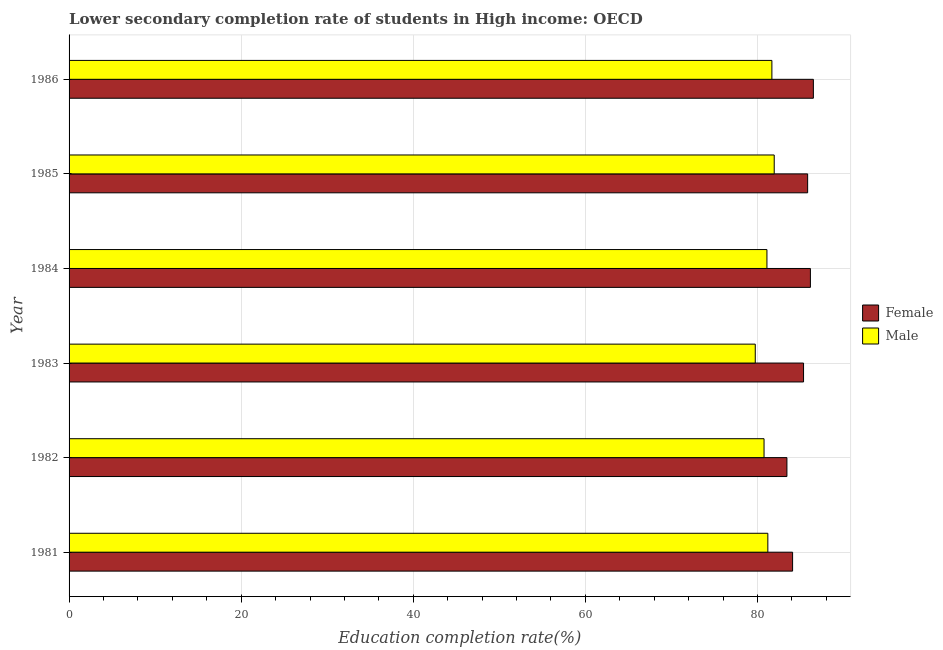How many different coloured bars are there?
Your response must be concise. 2. How many groups of bars are there?
Give a very brief answer. 6. Are the number of bars per tick equal to the number of legend labels?
Provide a short and direct response. Yes. Are the number of bars on each tick of the Y-axis equal?
Give a very brief answer. Yes. How many bars are there on the 3rd tick from the top?
Provide a short and direct response. 2. How many bars are there on the 1st tick from the bottom?
Make the answer very short. 2. What is the education completion rate of female students in 1982?
Offer a terse response. 83.43. Across all years, what is the maximum education completion rate of female students?
Offer a very short reply. 86.5. Across all years, what is the minimum education completion rate of male students?
Your answer should be compact. 79.75. In which year was the education completion rate of female students maximum?
Keep it short and to the point. 1986. In which year was the education completion rate of female students minimum?
Provide a succinct answer. 1982. What is the total education completion rate of male students in the graph?
Give a very brief answer. 486.46. What is the difference between the education completion rate of female students in 1981 and that in 1986?
Offer a terse response. -2.41. What is the difference between the education completion rate of female students in 1986 and the education completion rate of male students in 1983?
Your answer should be very brief. 6.75. What is the average education completion rate of male students per year?
Offer a very short reply. 81.08. In the year 1986, what is the difference between the education completion rate of female students and education completion rate of male students?
Make the answer very short. 4.82. In how many years, is the education completion rate of female students greater than 84 %?
Make the answer very short. 5. What is the ratio of the education completion rate of female students in 1983 to that in 1986?
Provide a short and direct response. 0.99. What is the difference between the highest and the second highest education completion rate of male students?
Provide a short and direct response. 0.27. What is the difference between the highest and the lowest education completion rate of male students?
Provide a short and direct response. 2.2. Is the sum of the education completion rate of male students in 1985 and 1986 greater than the maximum education completion rate of female students across all years?
Provide a succinct answer. Yes. What does the 1st bar from the top in 1983 represents?
Provide a succinct answer. Male. What does the 2nd bar from the bottom in 1985 represents?
Your answer should be compact. Male. Are all the bars in the graph horizontal?
Offer a very short reply. Yes. What is the difference between two consecutive major ticks on the X-axis?
Your answer should be very brief. 20. Are the values on the major ticks of X-axis written in scientific E-notation?
Make the answer very short. No. Does the graph contain grids?
Your response must be concise. Yes. Where does the legend appear in the graph?
Your answer should be compact. Center right. How many legend labels are there?
Your response must be concise. 2. How are the legend labels stacked?
Ensure brevity in your answer.  Vertical. What is the title of the graph?
Provide a succinct answer. Lower secondary completion rate of students in High income: OECD. Does "Females" appear as one of the legend labels in the graph?
Give a very brief answer. No. What is the label or title of the X-axis?
Provide a succinct answer. Education completion rate(%). What is the Education completion rate(%) in Female in 1981?
Provide a short and direct response. 84.09. What is the Education completion rate(%) in Male in 1981?
Ensure brevity in your answer.  81.21. What is the Education completion rate(%) in Female in 1982?
Provide a succinct answer. 83.43. What is the Education completion rate(%) of Male in 1982?
Your answer should be compact. 80.77. What is the Education completion rate(%) in Female in 1983?
Keep it short and to the point. 85.36. What is the Education completion rate(%) in Male in 1983?
Provide a short and direct response. 79.75. What is the Education completion rate(%) of Female in 1984?
Provide a succinct answer. 86.16. What is the Education completion rate(%) of Male in 1984?
Your response must be concise. 81.1. What is the Education completion rate(%) of Female in 1985?
Your answer should be compact. 85.83. What is the Education completion rate(%) of Male in 1985?
Provide a short and direct response. 81.95. What is the Education completion rate(%) in Female in 1986?
Provide a succinct answer. 86.5. What is the Education completion rate(%) in Male in 1986?
Your answer should be compact. 81.68. Across all years, what is the maximum Education completion rate(%) of Female?
Provide a short and direct response. 86.5. Across all years, what is the maximum Education completion rate(%) of Male?
Your answer should be very brief. 81.95. Across all years, what is the minimum Education completion rate(%) in Female?
Provide a succinct answer. 83.43. Across all years, what is the minimum Education completion rate(%) of Male?
Give a very brief answer. 79.75. What is the total Education completion rate(%) in Female in the graph?
Offer a terse response. 511.36. What is the total Education completion rate(%) of Male in the graph?
Keep it short and to the point. 486.46. What is the difference between the Education completion rate(%) of Female in 1981 and that in 1982?
Ensure brevity in your answer.  0.66. What is the difference between the Education completion rate(%) of Male in 1981 and that in 1982?
Provide a succinct answer. 0.44. What is the difference between the Education completion rate(%) in Female in 1981 and that in 1983?
Your answer should be compact. -1.27. What is the difference between the Education completion rate(%) in Male in 1981 and that in 1983?
Ensure brevity in your answer.  1.46. What is the difference between the Education completion rate(%) in Female in 1981 and that in 1984?
Keep it short and to the point. -2.07. What is the difference between the Education completion rate(%) in Male in 1981 and that in 1984?
Provide a succinct answer. 0.11. What is the difference between the Education completion rate(%) of Female in 1981 and that in 1985?
Make the answer very short. -1.75. What is the difference between the Education completion rate(%) of Male in 1981 and that in 1985?
Keep it short and to the point. -0.74. What is the difference between the Education completion rate(%) of Female in 1981 and that in 1986?
Your response must be concise. -2.41. What is the difference between the Education completion rate(%) in Male in 1981 and that in 1986?
Provide a short and direct response. -0.47. What is the difference between the Education completion rate(%) of Female in 1982 and that in 1983?
Give a very brief answer. -1.93. What is the difference between the Education completion rate(%) of Male in 1982 and that in 1983?
Offer a very short reply. 1.02. What is the difference between the Education completion rate(%) of Female in 1982 and that in 1984?
Provide a short and direct response. -2.73. What is the difference between the Education completion rate(%) of Male in 1982 and that in 1984?
Offer a very short reply. -0.34. What is the difference between the Education completion rate(%) of Female in 1982 and that in 1985?
Offer a very short reply. -2.41. What is the difference between the Education completion rate(%) in Male in 1982 and that in 1985?
Your answer should be very brief. -1.18. What is the difference between the Education completion rate(%) in Female in 1982 and that in 1986?
Offer a very short reply. -3.07. What is the difference between the Education completion rate(%) in Male in 1982 and that in 1986?
Provide a short and direct response. -0.91. What is the difference between the Education completion rate(%) of Female in 1983 and that in 1984?
Provide a short and direct response. -0.8. What is the difference between the Education completion rate(%) of Male in 1983 and that in 1984?
Ensure brevity in your answer.  -1.36. What is the difference between the Education completion rate(%) of Female in 1983 and that in 1985?
Offer a very short reply. -0.48. What is the difference between the Education completion rate(%) of Male in 1983 and that in 1985?
Keep it short and to the point. -2.2. What is the difference between the Education completion rate(%) in Female in 1983 and that in 1986?
Provide a succinct answer. -1.14. What is the difference between the Education completion rate(%) of Male in 1983 and that in 1986?
Keep it short and to the point. -1.93. What is the difference between the Education completion rate(%) of Female in 1984 and that in 1985?
Give a very brief answer. 0.32. What is the difference between the Education completion rate(%) of Male in 1984 and that in 1985?
Provide a short and direct response. -0.85. What is the difference between the Education completion rate(%) in Female in 1984 and that in 1986?
Offer a terse response. -0.34. What is the difference between the Education completion rate(%) of Male in 1984 and that in 1986?
Your answer should be compact. -0.58. What is the difference between the Education completion rate(%) of Female in 1985 and that in 1986?
Make the answer very short. -0.67. What is the difference between the Education completion rate(%) in Male in 1985 and that in 1986?
Provide a succinct answer. 0.27. What is the difference between the Education completion rate(%) in Female in 1981 and the Education completion rate(%) in Male in 1982?
Ensure brevity in your answer.  3.32. What is the difference between the Education completion rate(%) of Female in 1981 and the Education completion rate(%) of Male in 1983?
Provide a succinct answer. 4.34. What is the difference between the Education completion rate(%) of Female in 1981 and the Education completion rate(%) of Male in 1984?
Ensure brevity in your answer.  2.98. What is the difference between the Education completion rate(%) in Female in 1981 and the Education completion rate(%) in Male in 1985?
Your answer should be very brief. 2.14. What is the difference between the Education completion rate(%) in Female in 1981 and the Education completion rate(%) in Male in 1986?
Ensure brevity in your answer.  2.41. What is the difference between the Education completion rate(%) of Female in 1982 and the Education completion rate(%) of Male in 1983?
Ensure brevity in your answer.  3.68. What is the difference between the Education completion rate(%) in Female in 1982 and the Education completion rate(%) in Male in 1984?
Offer a terse response. 2.32. What is the difference between the Education completion rate(%) of Female in 1982 and the Education completion rate(%) of Male in 1985?
Provide a short and direct response. 1.48. What is the difference between the Education completion rate(%) of Female in 1982 and the Education completion rate(%) of Male in 1986?
Keep it short and to the point. 1.75. What is the difference between the Education completion rate(%) of Female in 1983 and the Education completion rate(%) of Male in 1984?
Provide a succinct answer. 4.25. What is the difference between the Education completion rate(%) of Female in 1983 and the Education completion rate(%) of Male in 1985?
Your response must be concise. 3.41. What is the difference between the Education completion rate(%) of Female in 1983 and the Education completion rate(%) of Male in 1986?
Provide a short and direct response. 3.68. What is the difference between the Education completion rate(%) in Female in 1984 and the Education completion rate(%) in Male in 1985?
Your response must be concise. 4.21. What is the difference between the Education completion rate(%) in Female in 1984 and the Education completion rate(%) in Male in 1986?
Provide a short and direct response. 4.48. What is the difference between the Education completion rate(%) in Female in 1985 and the Education completion rate(%) in Male in 1986?
Your response must be concise. 4.15. What is the average Education completion rate(%) of Female per year?
Your answer should be compact. 85.23. What is the average Education completion rate(%) of Male per year?
Your answer should be compact. 81.08. In the year 1981, what is the difference between the Education completion rate(%) of Female and Education completion rate(%) of Male?
Give a very brief answer. 2.88. In the year 1982, what is the difference between the Education completion rate(%) in Female and Education completion rate(%) in Male?
Your answer should be compact. 2.66. In the year 1983, what is the difference between the Education completion rate(%) of Female and Education completion rate(%) of Male?
Your answer should be compact. 5.61. In the year 1984, what is the difference between the Education completion rate(%) of Female and Education completion rate(%) of Male?
Provide a succinct answer. 5.05. In the year 1985, what is the difference between the Education completion rate(%) in Female and Education completion rate(%) in Male?
Ensure brevity in your answer.  3.88. In the year 1986, what is the difference between the Education completion rate(%) in Female and Education completion rate(%) in Male?
Your response must be concise. 4.82. What is the ratio of the Education completion rate(%) in Female in 1981 to that in 1982?
Your answer should be very brief. 1.01. What is the ratio of the Education completion rate(%) in Female in 1981 to that in 1983?
Offer a terse response. 0.99. What is the ratio of the Education completion rate(%) in Male in 1981 to that in 1983?
Offer a very short reply. 1.02. What is the ratio of the Education completion rate(%) of Female in 1981 to that in 1985?
Provide a succinct answer. 0.98. What is the ratio of the Education completion rate(%) in Female in 1981 to that in 1986?
Offer a terse response. 0.97. What is the ratio of the Education completion rate(%) of Male in 1981 to that in 1986?
Provide a short and direct response. 0.99. What is the ratio of the Education completion rate(%) in Female in 1982 to that in 1983?
Make the answer very short. 0.98. What is the ratio of the Education completion rate(%) in Male in 1982 to that in 1983?
Your answer should be compact. 1.01. What is the ratio of the Education completion rate(%) of Female in 1982 to that in 1984?
Offer a terse response. 0.97. What is the ratio of the Education completion rate(%) in Male in 1982 to that in 1985?
Your answer should be very brief. 0.99. What is the ratio of the Education completion rate(%) in Female in 1982 to that in 1986?
Your answer should be compact. 0.96. What is the ratio of the Education completion rate(%) of Male in 1982 to that in 1986?
Your response must be concise. 0.99. What is the ratio of the Education completion rate(%) of Female in 1983 to that in 1984?
Your answer should be compact. 0.99. What is the ratio of the Education completion rate(%) in Male in 1983 to that in 1984?
Keep it short and to the point. 0.98. What is the ratio of the Education completion rate(%) in Female in 1983 to that in 1985?
Make the answer very short. 0.99. What is the ratio of the Education completion rate(%) of Male in 1983 to that in 1985?
Keep it short and to the point. 0.97. What is the ratio of the Education completion rate(%) in Male in 1983 to that in 1986?
Make the answer very short. 0.98. What is the ratio of the Education completion rate(%) of Female in 1984 to that in 1985?
Make the answer very short. 1. What is the ratio of the Education completion rate(%) of Male in 1984 to that in 1985?
Provide a succinct answer. 0.99. What is the ratio of the Education completion rate(%) of Female in 1984 to that in 1986?
Provide a short and direct response. 1. What is the ratio of the Education completion rate(%) in Male in 1984 to that in 1986?
Make the answer very short. 0.99. What is the ratio of the Education completion rate(%) of Female in 1985 to that in 1986?
Give a very brief answer. 0.99. What is the ratio of the Education completion rate(%) in Male in 1985 to that in 1986?
Offer a very short reply. 1. What is the difference between the highest and the second highest Education completion rate(%) in Female?
Provide a short and direct response. 0.34. What is the difference between the highest and the second highest Education completion rate(%) of Male?
Give a very brief answer. 0.27. What is the difference between the highest and the lowest Education completion rate(%) of Female?
Offer a very short reply. 3.07. What is the difference between the highest and the lowest Education completion rate(%) of Male?
Make the answer very short. 2.2. 